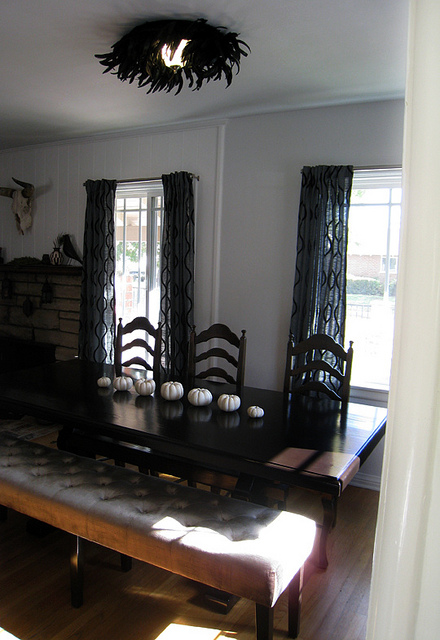<image>What kind of skeleton is in the picture? I don't know what kind of skeleton is in the picture. It might be a bull, cow, steer, bird, deer or there might not be any skeleton. What kind of skeleton is in the picture? I don't know what kind of skeleton is in the picture. It can be seen 'bull', 'cow', 'steer', 'bird', or 'deer'. 